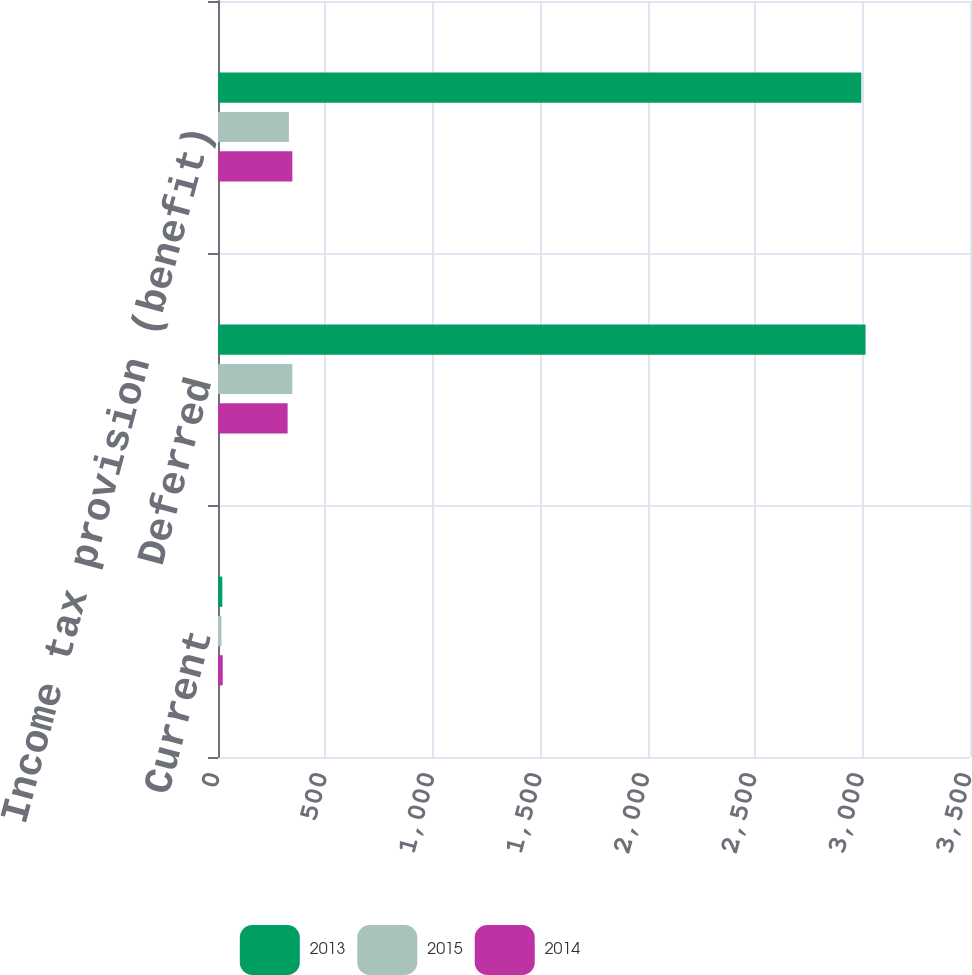Convert chart to OTSL. <chart><loc_0><loc_0><loc_500><loc_500><stacked_bar_chart><ecel><fcel>Current<fcel>Deferred<fcel>Income tax provision (benefit)<nl><fcel>2013<fcel>20<fcel>3014<fcel>2994<nl><fcel>2015<fcel>16<fcel>346<fcel>330<nl><fcel>2014<fcel>22<fcel>324<fcel>346<nl></chart> 